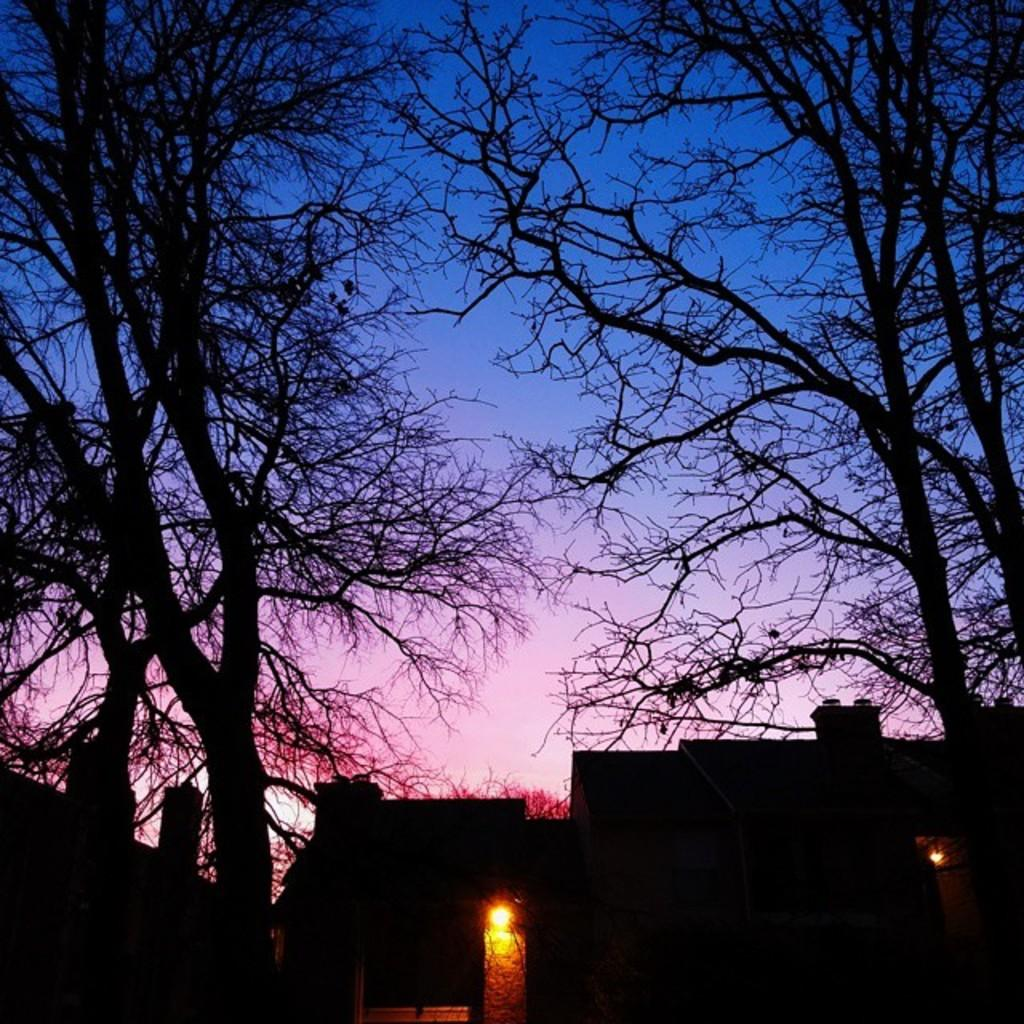What type of structures are present in the image? There are houses in the image. What feature can be seen on the houses? The houses have chimneys. What type of vegetation is present in the image? There are dried trees in the image. What is the condition of the dried trees? The dried trees have no leaves. What type of thrill can be seen on the front of the houses in the image? There is no mention of any thrill or excitement in the image; it features houses with chimneys and dried trees without leaves. Can you tell me how many dogs are present in the image? There are no dogs visible in the image. 